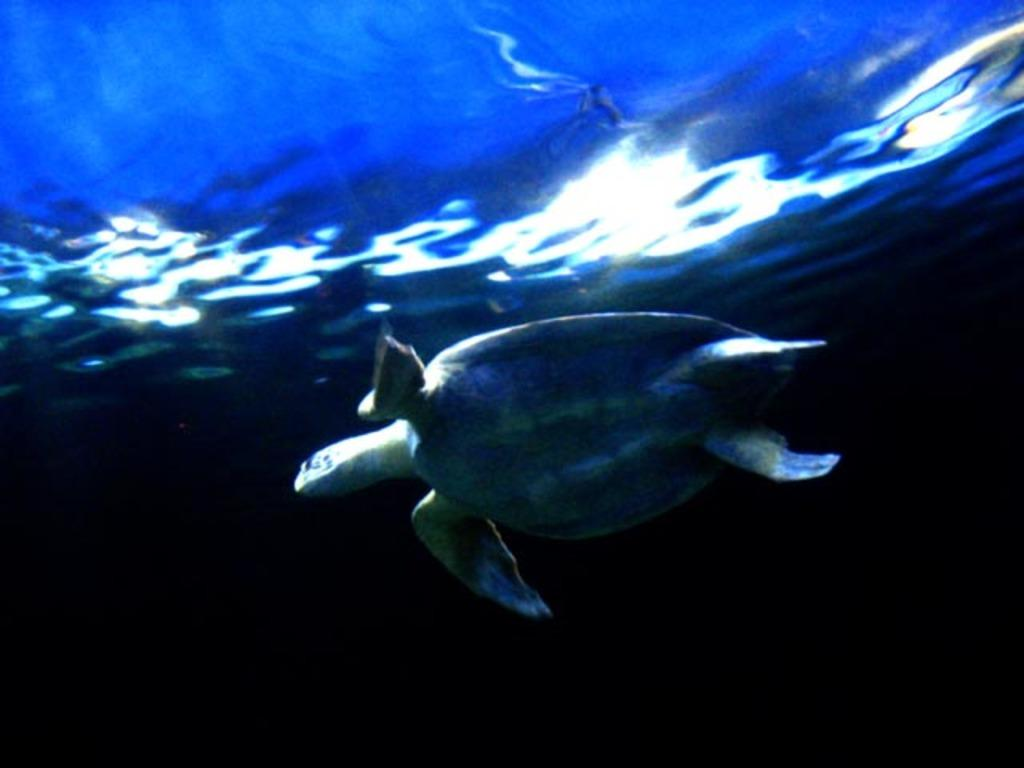What animal is present in the image? There is a tortoise in the image. Where is the tortoise located? The tortoise is in the water. What type of nose does the tortoise have in the image? The tortoise does not have a nose in the image; it has a beak-like mouth. 